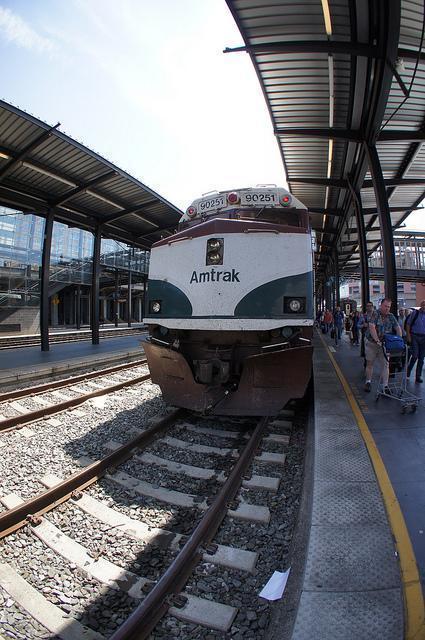How many orange cars are there in the picture?
Give a very brief answer. 0. 